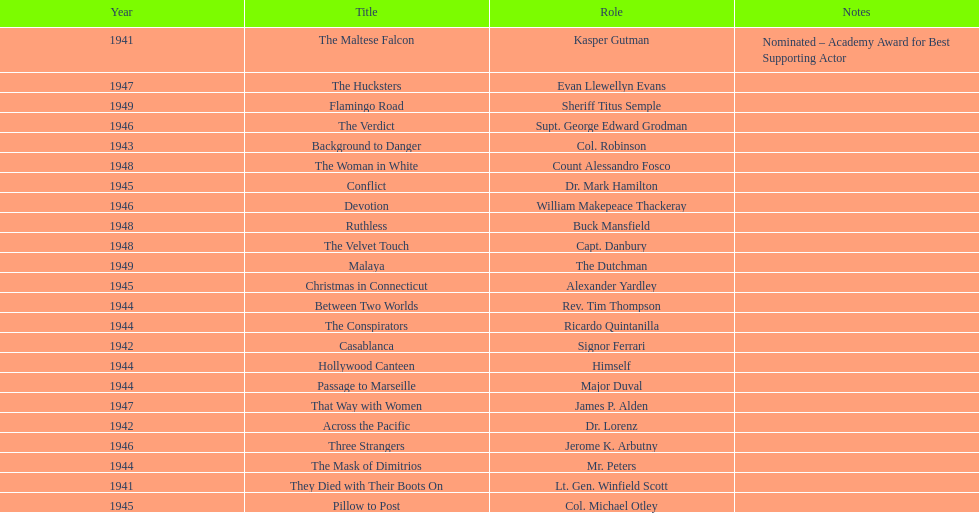How many movies has he been from 1941-1949. 23. 